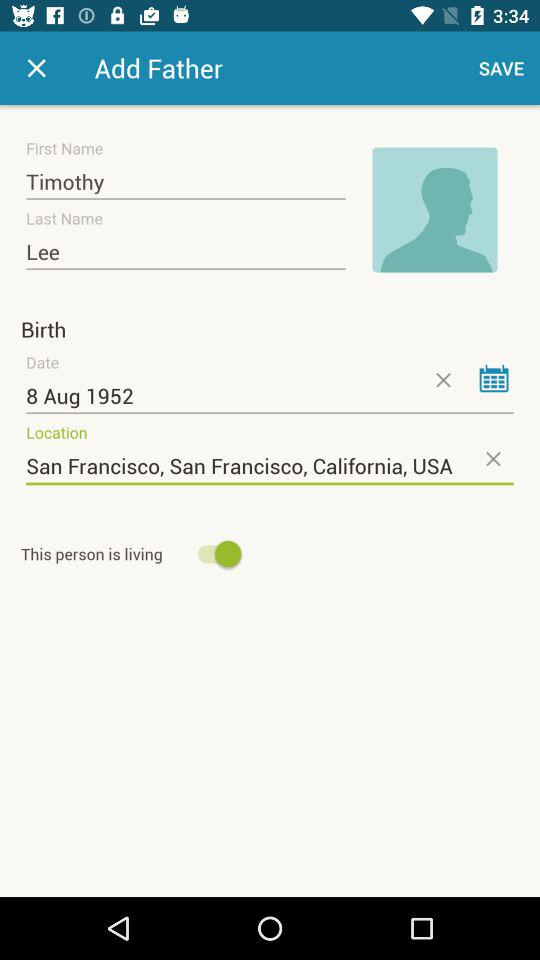What is the last name of the user? The last name of the user is Lee. 